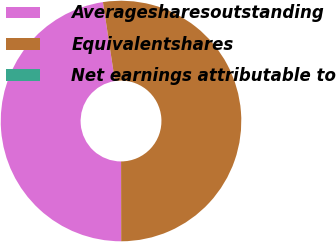<chart> <loc_0><loc_0><loc_500><loc_500><pie_chart><fcel>Averagesharesoutstanding<fcel>Equivalentshares<fcel>Net earnings attributable to<nl><fcel>47.62%<fcel>52.38%<fcel>0.0%<nl></chart> 